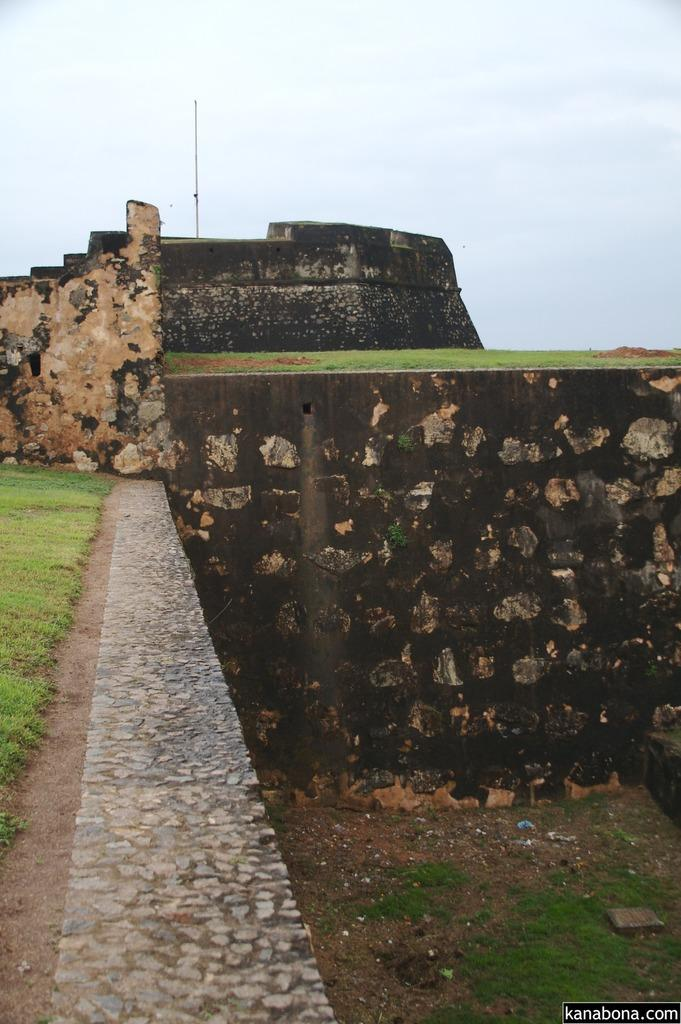What type of vegetation is present in the image? There is grass in the image. What type of architectural feature can be seen in the image? There are walls in the image. Where is the text located in the image? The text is at the right bottom of the image. What type of structure is present in the stomach of the person in the image? There is no person present in the image, and therefore no stomach or internal structures can be observed. 